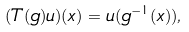<formula> <loc_0><loc_0><loc_500><loc_500>( T ( g ) u ) ( x ) = u ( g ^ { - 1 } ( x ) ) ,</formula> 